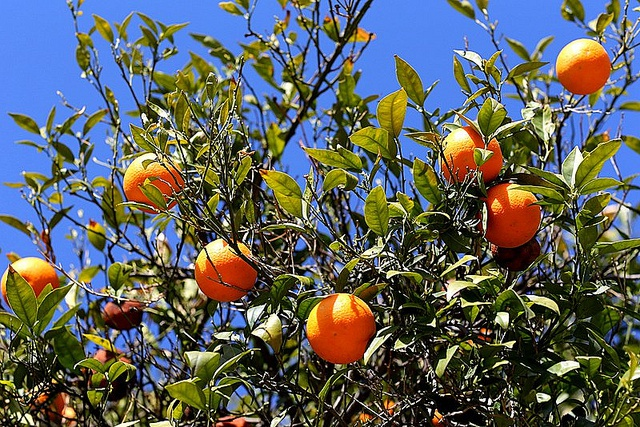Describe the objects in this image and their specific colors. I can see orange in lightblue, brown, red, and orange tones, orange in lightblue, brown, red, black, and maroon tones, orange in lightblue, maroon, red, and black tones, orange in lightblue, red, brown, and gold tones, and orange in lightblue, brown, red, and khaki tones in this image. 